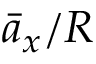Convert formula to latex. <formula><loc_0><loc_0><loc_500><loc_500>\bar { a } _ { x } / R</formula> 